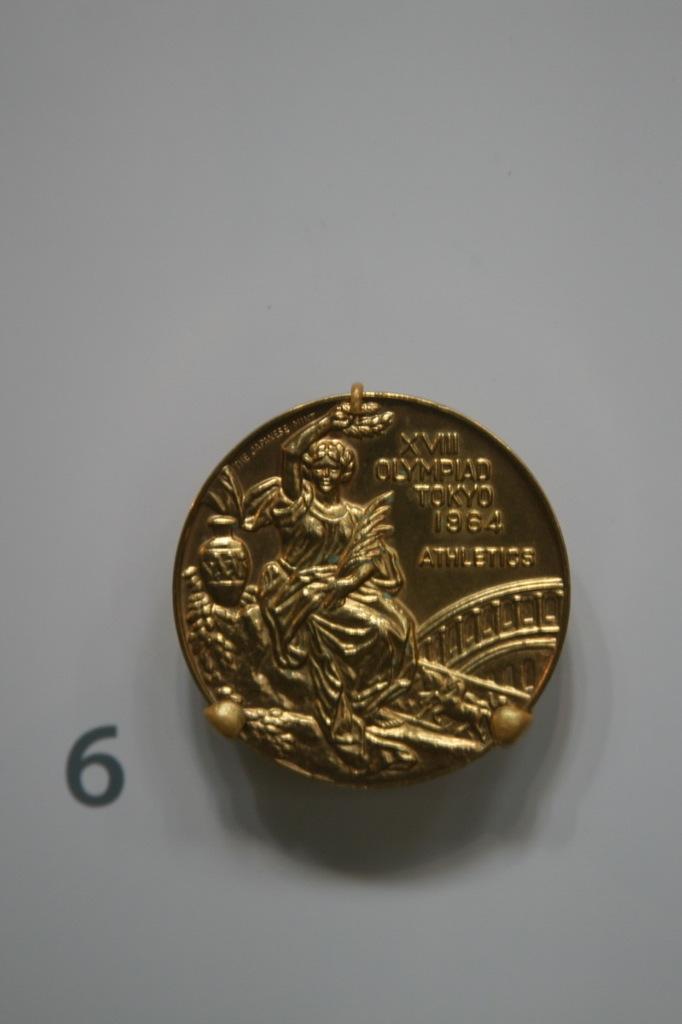What number is the coin next to?
Ensure brevity in your answer.  6. What year is on the coin?
Offer a terse response. 1964. 